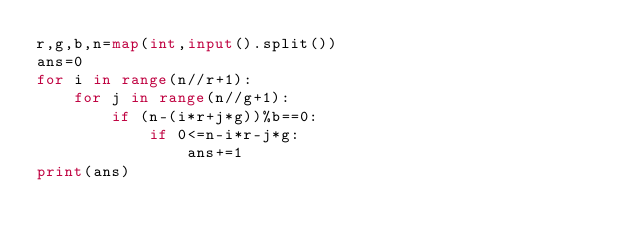Convert code to text. <code><loc_0><loc_0><loc_500><loc_500><_Python_>r,g,b,n=map(int,input().split())
ans=0
for i in range(n//r+1):
    for j in range(n//g+1):
        if (n-(i*r+j*g))%b==0:
            if 0<=n-i*r-j*g:
                ans+=1
print(ans)</code> 